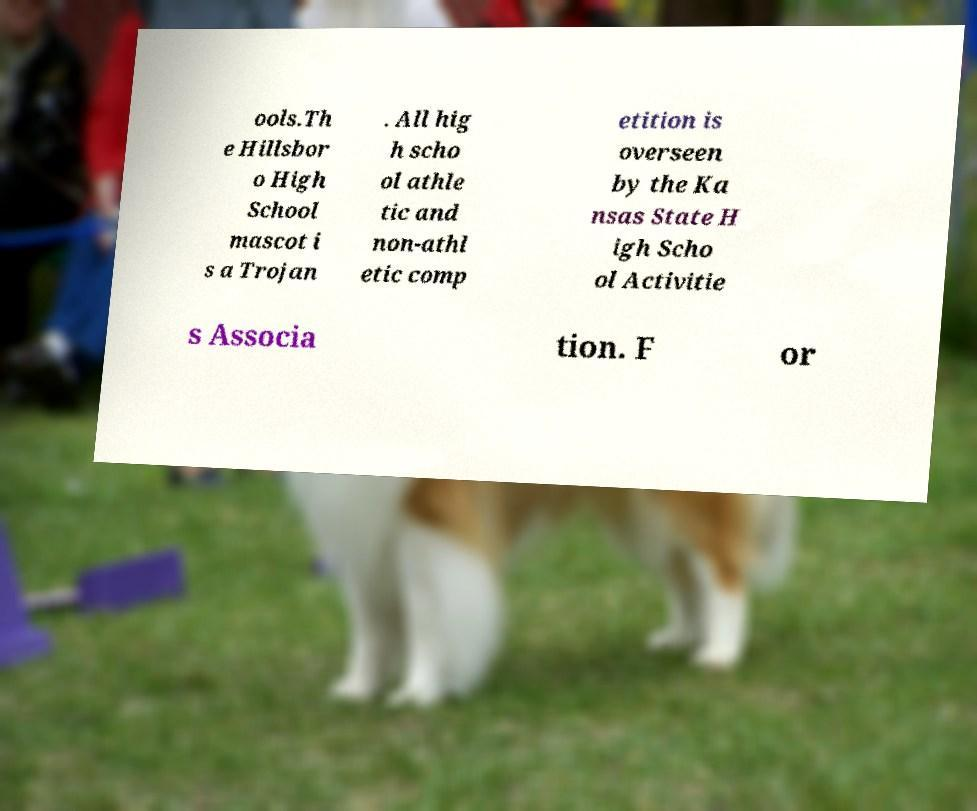What messages or text are displayed in this image? I need them in a readable, typed format. ools.Th e Hillsbor o High School mascot i s a Trojan . All hig h scho ol athle tic and non-athl etic comp etition is overseen by the Ka nsas State H igh Scho ol Activitie s Associa tion. F or 